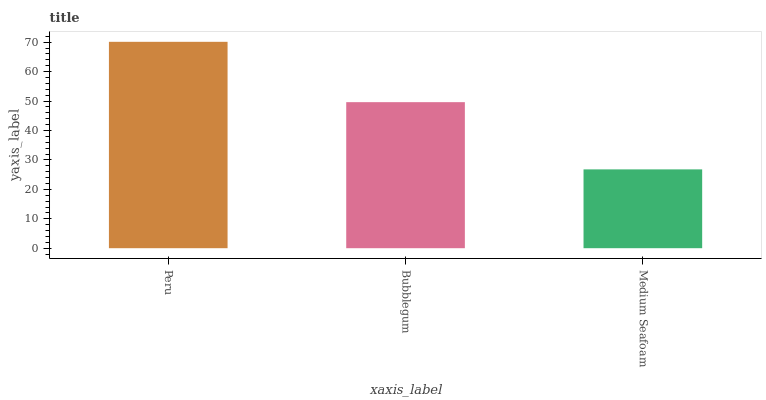Is Medium Seafoam the minimum?
Answer yes or no. Yes. Is Peru the maximum?
Answer yes or no. Yes. Is Bubblegum the minimum?
Answer yes or no. No. Is Bubblegum the maximum?
Answer yes or no. No. Is Peru greater than Bubblegum?
Answer yes or no. Yes. Is Bubblegum less than Peru?
Answer yes or no. Yes. Is Bubblegum greater than Peru?
Answer yes or no. No. Is Peru less than Bubblegum?
Answer yes or no. No. Is Bubblegum the high median?
Answer yes or no. Yes. Is Bubblegum the low median?
Answer yes or no. Yes. Is Peru the high median?
Answer yes or no. No. Is Peru the low median?
Answer yes or no. No. 